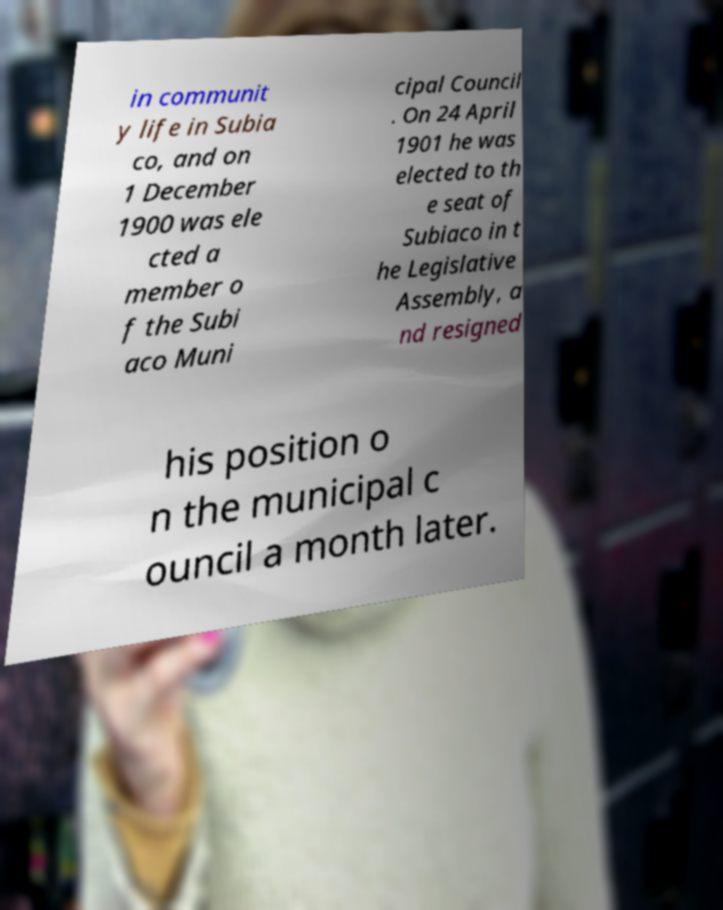What messages or text are displayed in this image? I need them in a readable, typed format. in communit y life in Subia co, and on 1 December 1900 was ele cted a member o f the Subi aco Muni cipal Council . On 24 April 1901 he was elected to th e seat of Subiaco in t he Legislative Assembly, a nd resigned his position o n the municipal c ouncil a month later. 